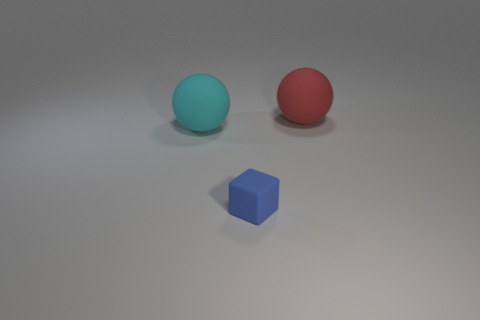There is a ball that is in front of the large rubber sphere that is on the right side of the tiny object; how big is it?
Offer a terse response. Large. What number of blocks are blue objects or purple objects?
Offer a terse response. 1. There is a thing that is the same size as the red rubber ball; what color is it?
Your response must be concise. Cyan. What shape is the big object that is to the left of the big rubber thing behind the cyan rubber ball?
Give a very brief answer. Sphere. Is the size of the red ball to the right of the blue matte block the same as the cyan rubber ball?
Make the answer very short. Yes. What number of other things are made of the same material as the blue block?
Your answer should be compact. 2. How many purple things are big objects or large rubber cylinders?
Make the answer very short. 0. There is a blue thing; what number of spheres are right of it?
Offer a terse response. 1. How big is the rubber block left of the large matte sphere right of the large cyan matte thing behind the blue object?
Give a very brief answer. Small. Is there a rubber object that is in front of the large sphere to the left of the big rubber thing to the right of the cyan rubber object?
Your answer should be very brief. Yes. 